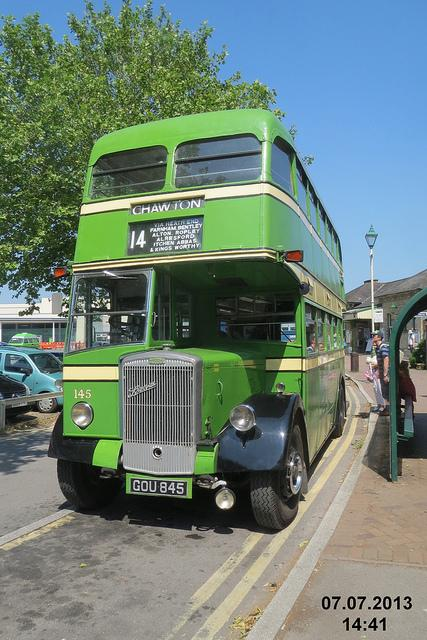In which country does this bus travel?

Choices:
A) united states
B) belize
C) chile
D) great britain great britain 